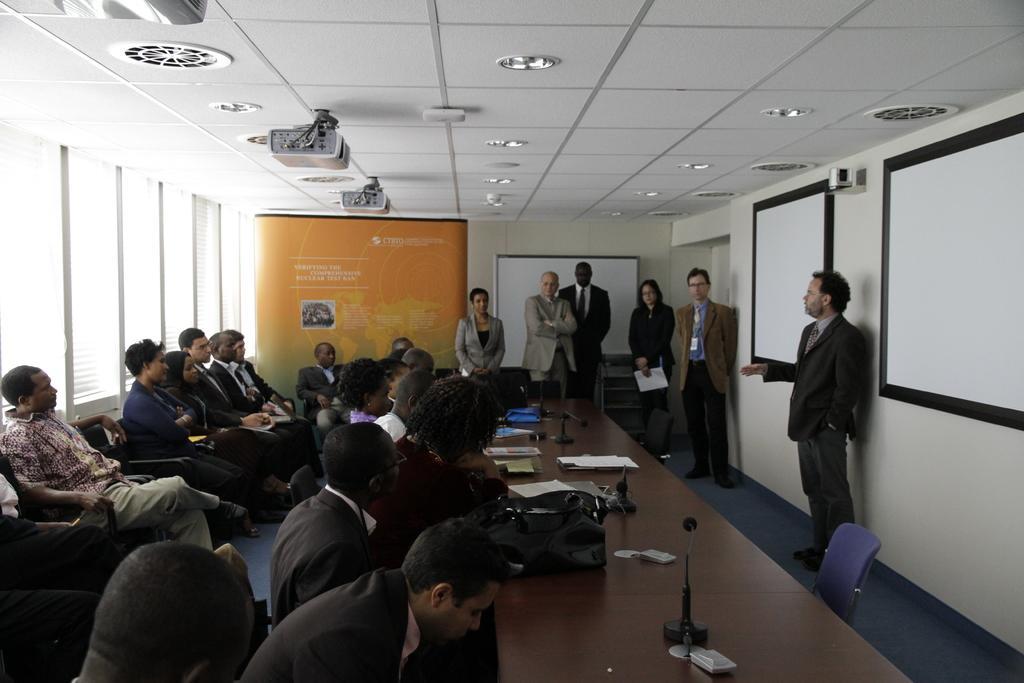How would you summarize this image in a sentence or two? In this image, we can see a conference room. There are some persons at the bottom of the image sitting in front of the table. There are some persons on the left side of the image sitting on chairs. There are some lights and projectors on the ceiling which is at the top of the image. There is a person on the right side of the image standing in front of screens. 